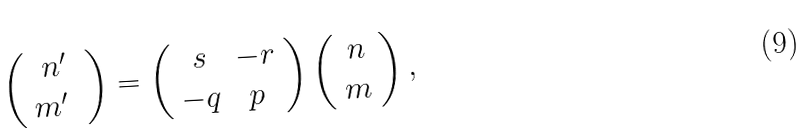Convert formula to latex. <formula><loc_0><loc_0><loc_500><loc_500>\left ( \begin{array} { c } n ^ { \prime } \\ m ^ { \prime } \ \end{array} \right ) = \left ( \begin{array} { c c } s & - r \\ - q & p \end{array} \right ) \left ( \begin{array} { c } n \\ m \end{array} \right ) ,</formula> 